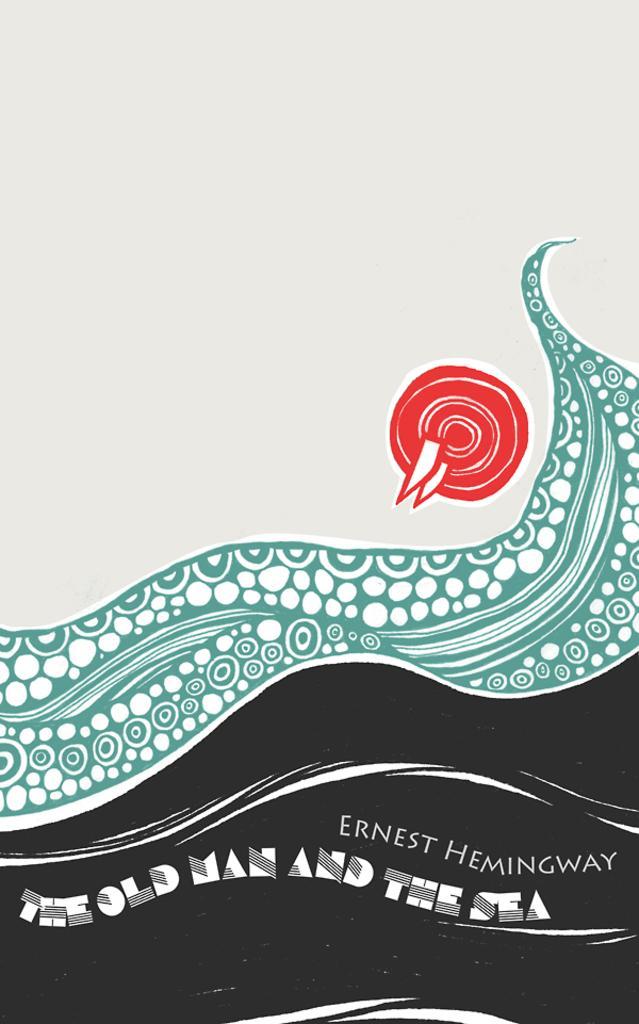Could you give a brief overview of what you see in this image? This is an animation. On the right side of the image we can see a logo. At the bottom of the image we can see the text. 